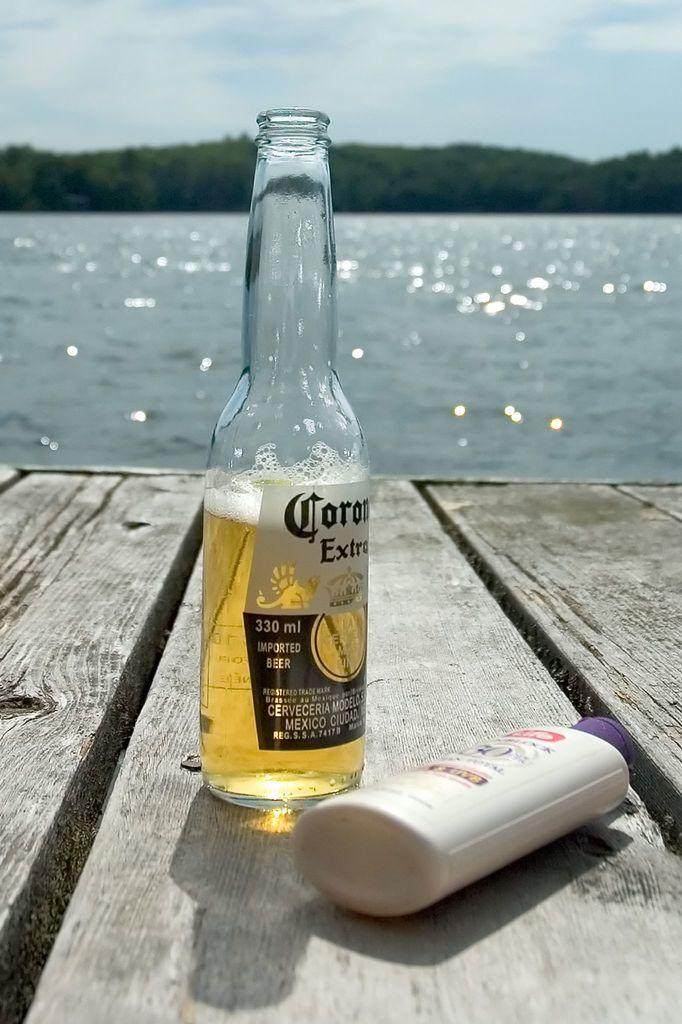What objects are on the table in the image? There are bottles on a table in the image. What is inside the bottles? The bottles contain a liquid and foam. What type of water body is depicted in the image? The image depicts a freshwater river. What can be seen in the distance in the image? There are trees visible in the distance. What invention is being demonstrated in the image? There is no invention being demonstrated in the image; it simply shows bottles on a table and a freshwater river with trees in the distance. What type of trade is taking place in the image? There is no trade taking place in the image; it is a scene of bottles on a table and a river with trees in the distance. 